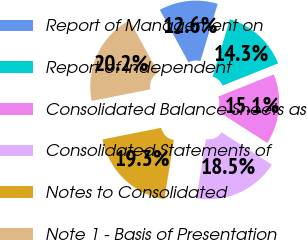Convert chart. <chart><loc_0><loc_0><loc_500><loc_500><pie_chart><fcel>Report of Management on<fcel>Report of Independent<fcel>Consolidated Balance Sheets as<fcel>Consolidated Statements of<fcel>Notes to Consolidated<fcel>Note 1 - Basis of Presentation<nl><fcel>12.62%<fcel>14.29%<fcel>15.13%<fcel>18.48%<fcel>19.32%<fcel>20.16%<nl></chart> 